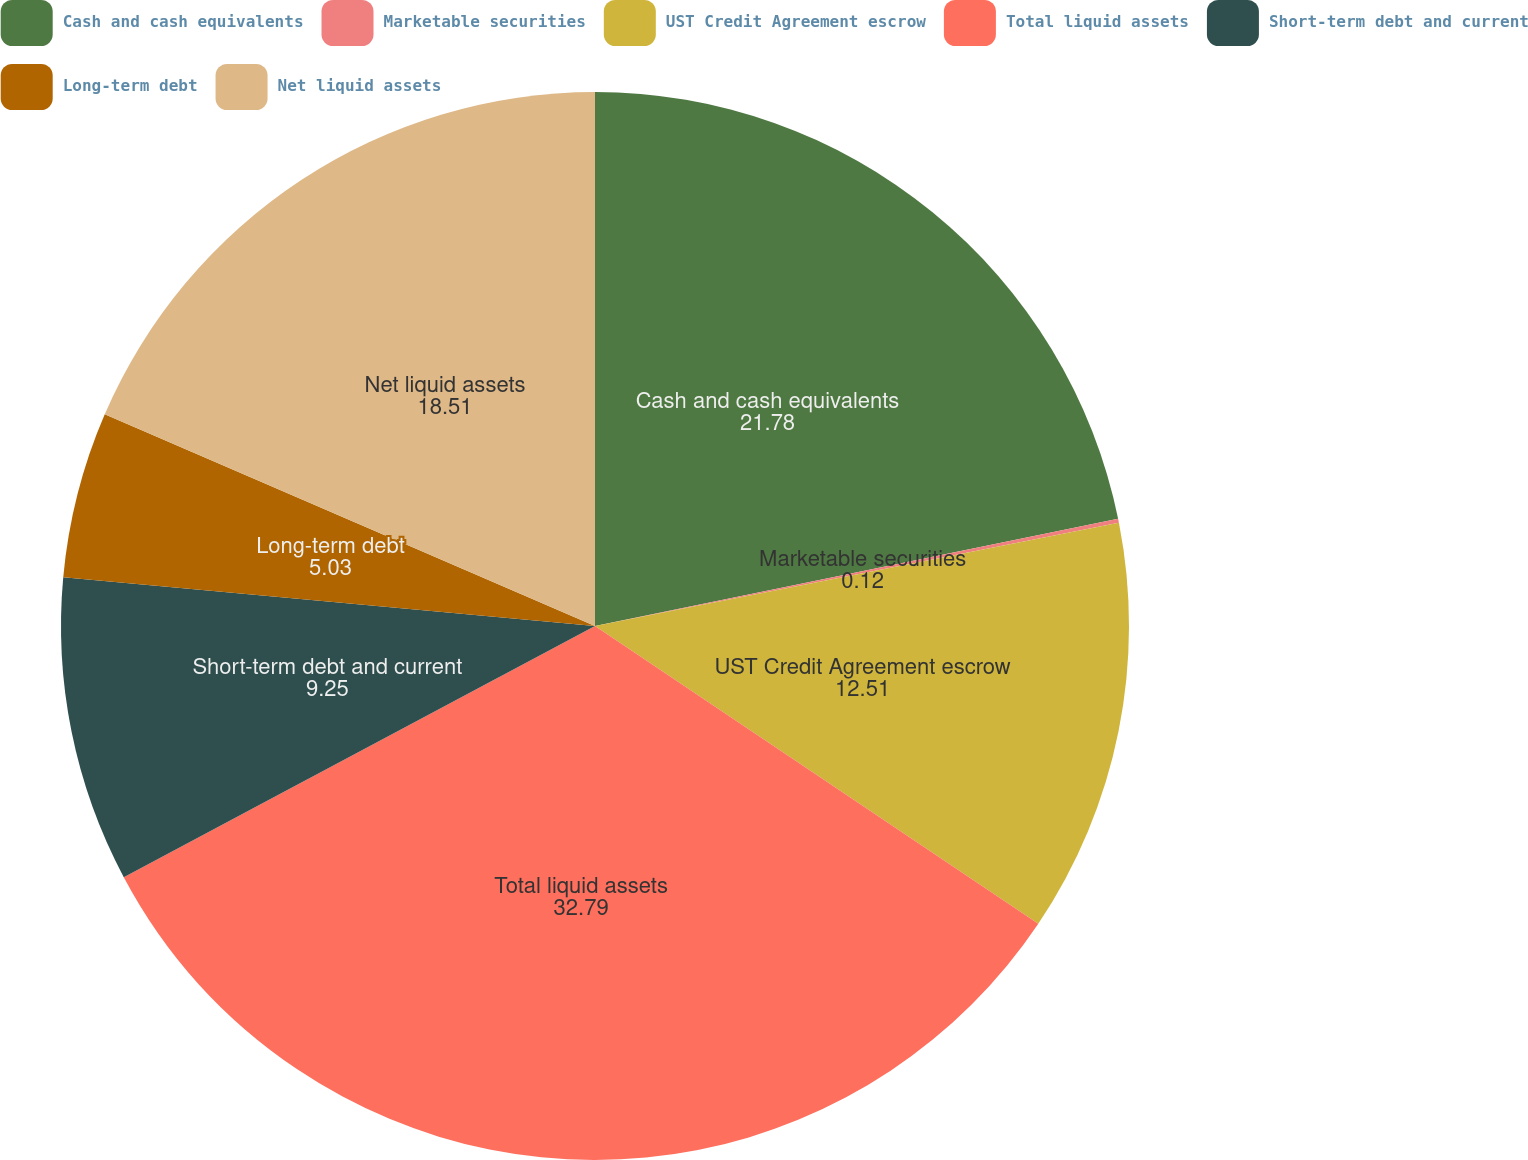Convert chart to OTSL. <chart><loc_0><loc_0><loc_500><loc_500><pie_chart><fcel>Cash and cash equivalents<fcel>Marketable securities<fcel>UST Credit Agreement escrow<fcel>Total liquid assets<fcel>Short-term debt and current<fcel>Long-term debt<fcel>Net liquid assets<nl><fcel>21.78%<fcel>0.12%<fcel>12.51%<fcel>32.79%<fcel>9.25%<fcel>5.03%<fcel>18.51%<nl></chart> 